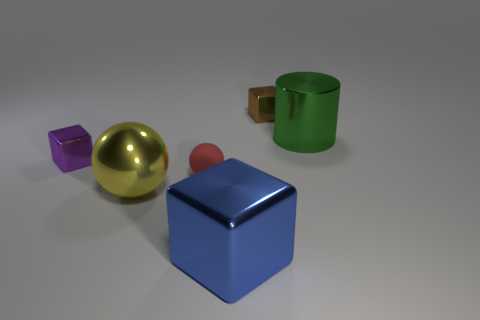What number of large objects are purple shiny things or shiny objects?
Keep it short and to the point. 3. Is the material of the small block on the right side of the purple thing the same as the small block that is in front of the big green cylinder?
Keep it short and to the point. Yes. There is a small cube behind the tiny purple cube; what material is it?
Keep it short and to the point. Metal. How many rubber objects are small yellow cylinders or large blue things?
Offer a terse response. 0. What is the color of the metal thing to the right of the small metallic block that is behind the large green metal cylinder?
Your response must be concise. Green. Does the green object have the same material as the yellow sphere in front of the small brown metal block?
Your answer should be very brief. Yes. What is the color of the block that is in front of the metal cube that is left of the big object in front of the large yellow object?
Provide a succinct answer. Blue. Is there anything else that is the same shape as the tiny purple shiny thing?
Your response must be concise. Yes. Is the number of large green shiny things greater than the number of small green cylinders?
Provide a short and direct response. Yes. What number of shiny things are behind the purple metal thing and to the left of the large green metal object?
Ensure brevity in your answer.  1. 